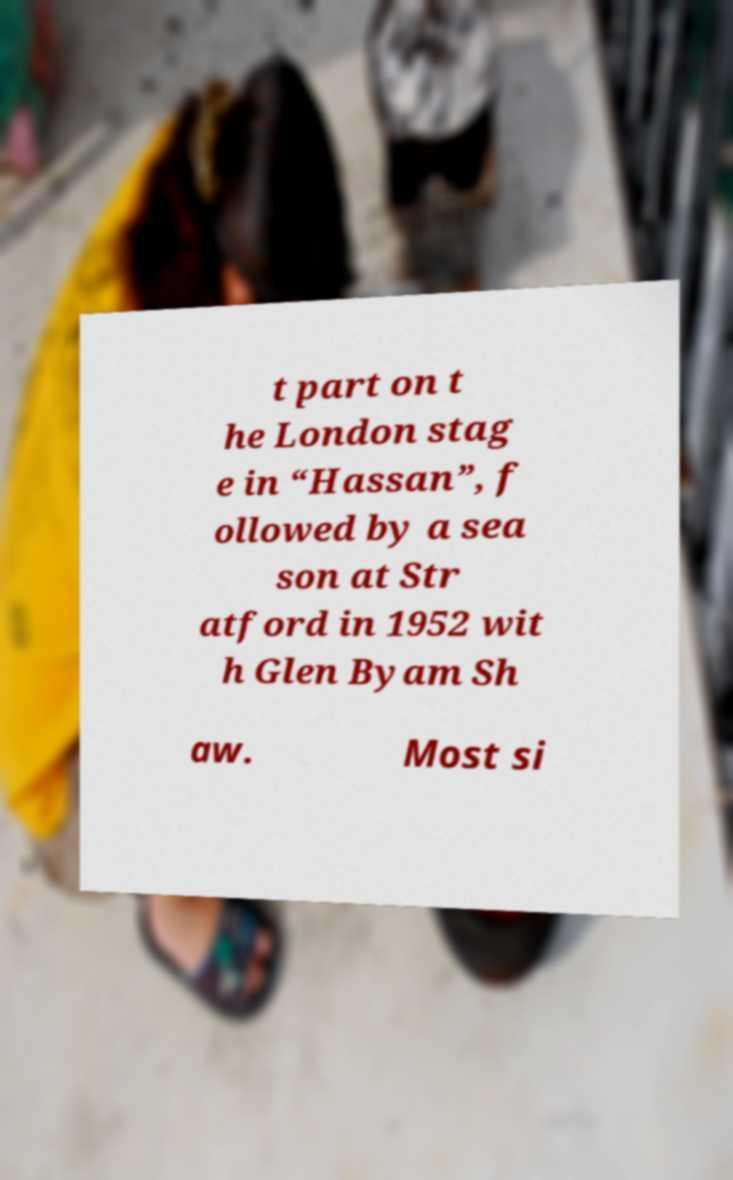Please identify and transcribe the text found in this image. t part on t he London stag e in “Hassan”, f ollowed by a sea son at Str atford in 1952 wit h Glen Byam Sh aw. Most si 